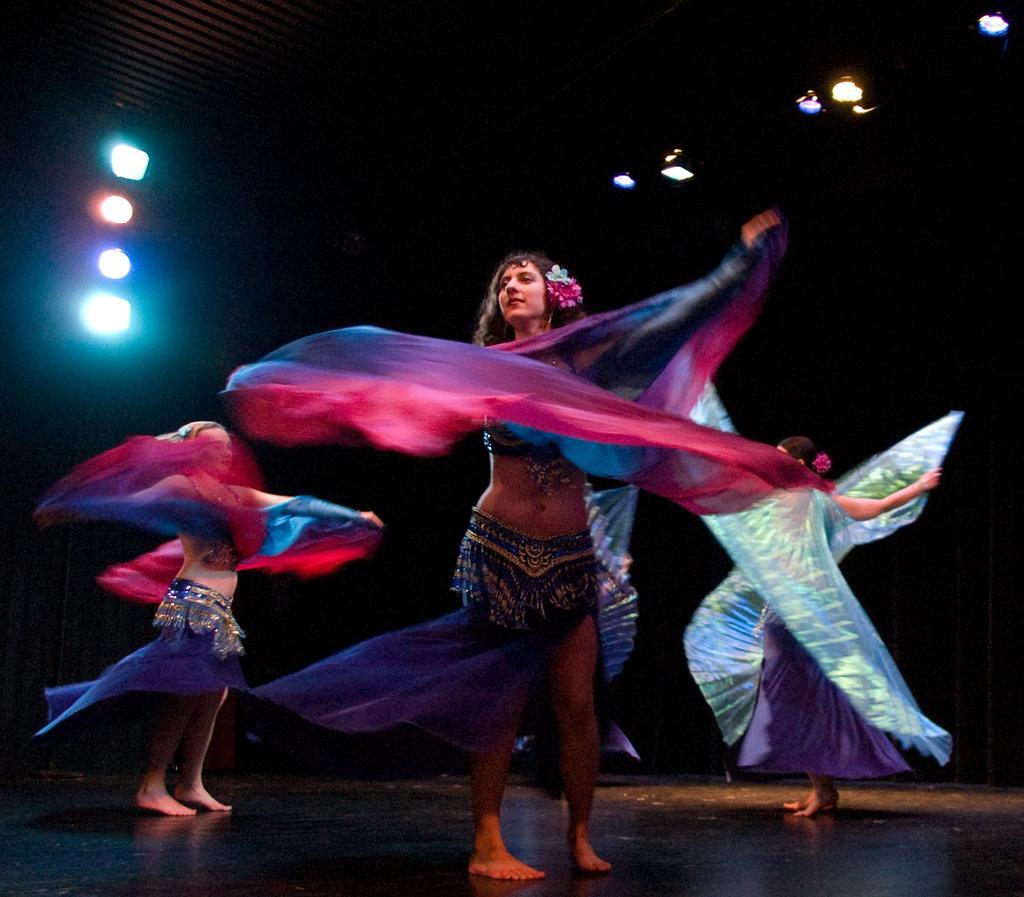Describe this image in one or two sentences. In this image, we can see three persons wearing clothes. There are lights in the top left and in the top right of the image. 